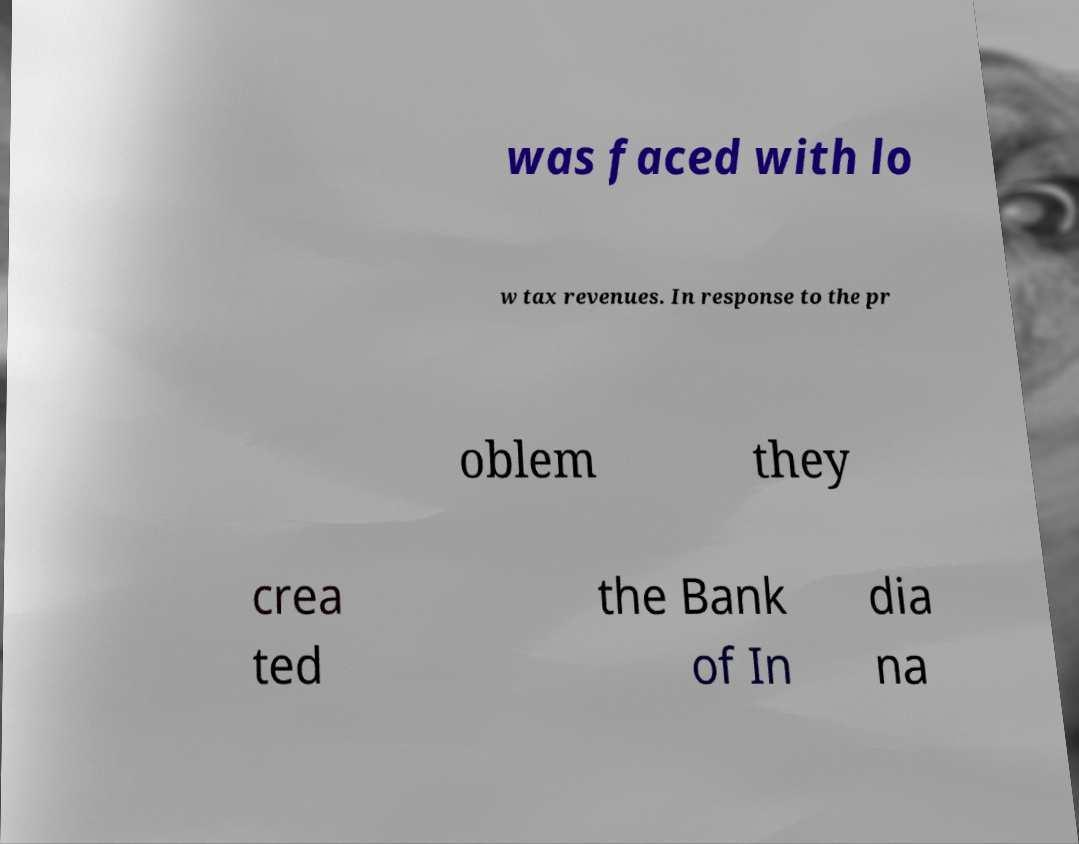I need the written content from this picture converted into text. Can you do that? was faced with lo w tax revenues. In response to the pr oblem they crea ted the Bank of In dia na 